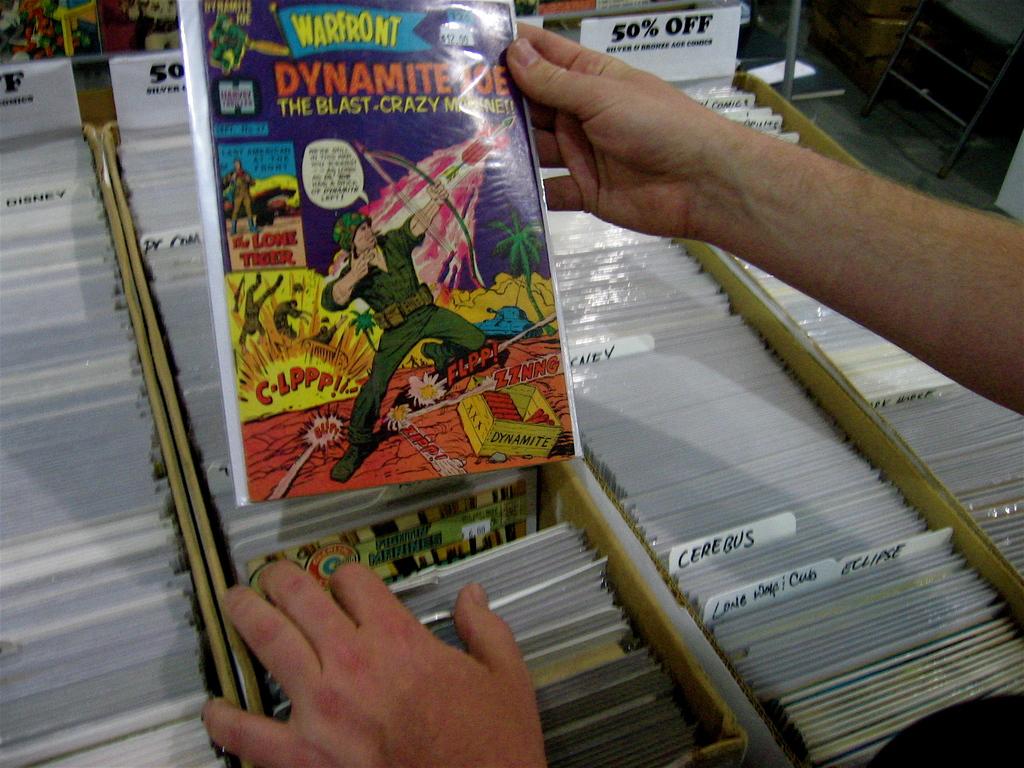What is in the yellow crate on the comic book cover?
Make the answer very short. Dynamite. 